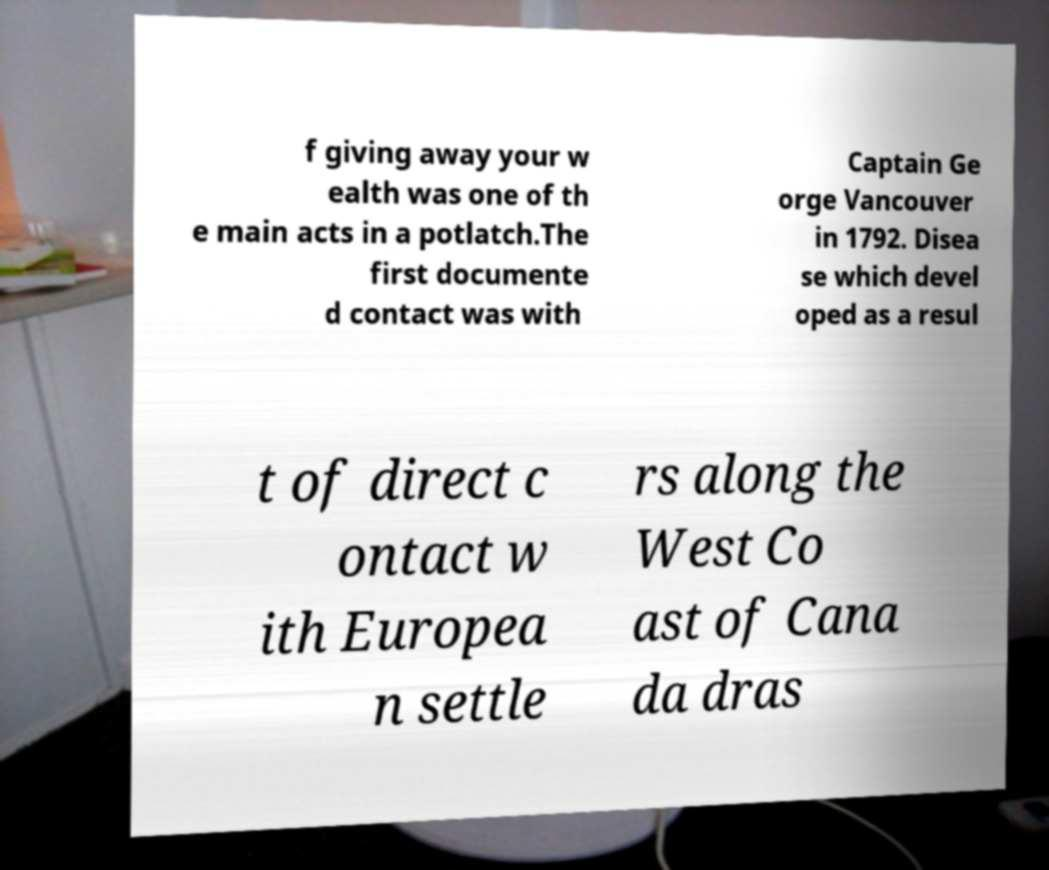Could you extract and type out the text from this image? f giving away your w ealth was one of th e main acts in a potlatch.The first documente d contact was with Captain Ge orge Vancouver in 1792. Disea se which devel oped as a resul t of direct c ontact w ith Europea n settle rs along the West Co ast of Cana da dras 